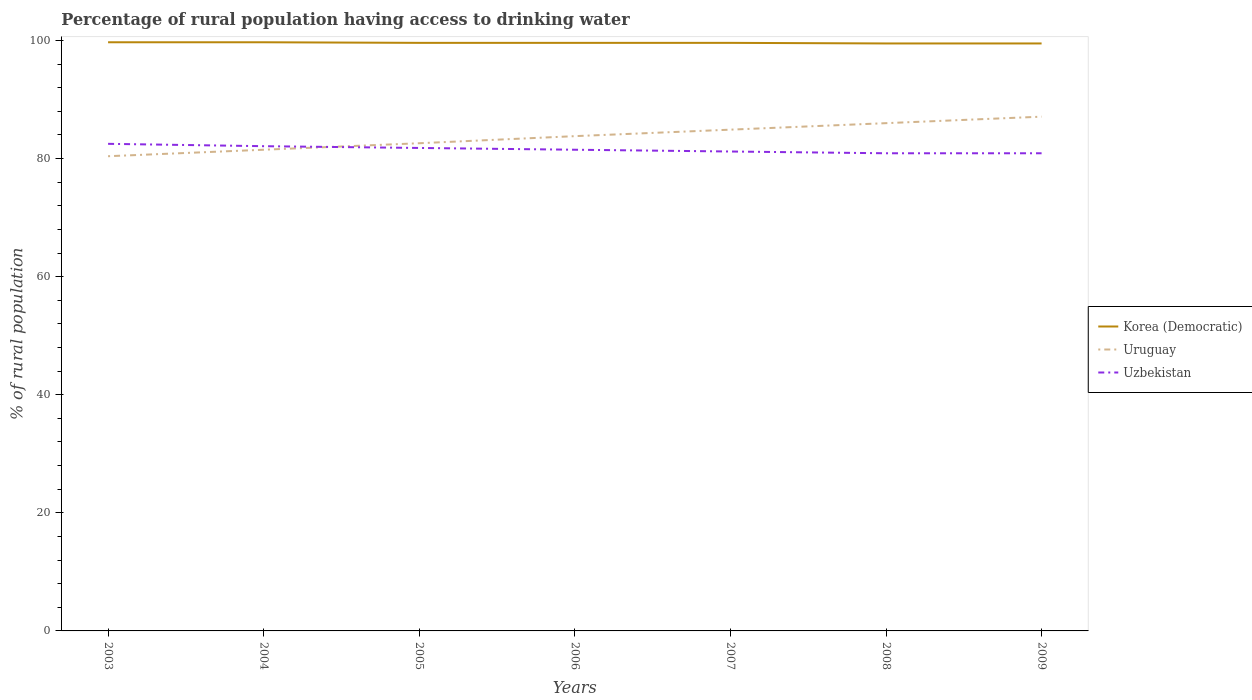How many different coloured lines are there?
Keep it short and to the point. 3. Across all years, what is the maximum percentage of rural population having access to drinking water in Uruguay?
Your answer should be compact. 80.4. What is the difference between the highest and the second highest percentage of rural population having access to drinking water in Korea (Democratic)?
Your answer should be very brief. 0.2. Is the percentage of rural population having access to drinking water in Korea (Democratic) strictly greater than the percentage of rural population having access to drinking water in Uruguay over the years?
Your answer should be very brief. No. How many lines are there?
Make the answer very short. 3. How many years are there in the graph?
Your response must be concise. 7. Are the values on the major ticks of Y-axis written in scientific E-notation?
Your answer should be compact. No. Does the graph contain any zero values?
Keep it short and to the point. No. Does the graph contain grids?
Make the answer very short. No. Where does the legend appear in the graph?
Provide a short and direct response. Center right. How many legend labels are there?
Provide a succinct answer. 3. How are the legend labels stacked?
Your response must be concise. Vertical. What is the title of the graph?
Offer a terse response. Percentage of rural population having access to drinking water. Does "Armenia" appear as one of the legend labels in the graph?
Give a very brief answer. No. What is the label or title of the X-axis?
Make the answer very short. Years. What is the label or title of the Y-axis?
Provide a short and direct response. % of rural population. What is the % of rural population of Korea (Democratic) in 2003?
Give a very brief answer. 99.7. What is the % of rural population of Uruguay in 2003?
Your answer should be very brief. 80.4. What is the % of rural population of Uzbekistan in 2003?
Your answer should be very brief. 82.5. What is the % of rural population of Korea (Democratic) in 2004?
Provide a succinct answer. 99.7. What is the % of rural population in Uruguay in 2004?
Your answer should be very brief. 81.5. What is the % of rural population in Uzbekistan in 2004?
Your response must be concise. 82.1. What is the % of rural population of Korea (Democratic) in 2005?
Offer a terse response. 99.6. What is the % of rural population in Uruguay in 2005?
Provide a short and direct response. 82.6. What is the % of rural population in Uzbekistan in 2005?
Offer a terse response. 81.8. What is the % of rural population in Korea (Democratic) in 2006?
Offer a terse response. 99.6. What is the % of rural population of Uruguay in 2006?
Your answer should be compact. 83.8. What is the % of rural population of Uzbekistan in 2006?
Give a very brief answer. 81.5. What is the % of rural population in Korea (Democratic) in 2007?
Your answer should be very brief. 99.6. What is the % of rural population of Uruguay in 2007?
Offer a terse response. 84.9. What is the % of rural population of Uzbekistan in 2007?
Make the answer very short. 81.2. What is the % of rural population in Korea (Democratic) in 2008?
Keep it short and to the point. 99.5. What is the % of rural population of Uruguay in 2008?
Ensure brevity in your answer.  86. What is the % of rural population of Uzbekistan in 2008?
Offer a very short reply. 80.9. What is the % of rural population of Korea (Democratic) in 2009?
Offer a terse response. 99.5. What is the % of rural population in Uruguay in 2009?
Keep it short and to the point. 87.1. What is the % of rural population of Uzbekistan in 2009?
Your response must be concise. 80.9. Across all years, what is the maximum % of rural population in Korea (Democratic)?
Your response must be concise. 99.7. Across all years, what is the maximum % of rural population of Uruguay?
Your answer should be compact. 87.1. Across all years, what is the maximum % of rural population of Uzbekistan?
Provide a succinct answer. 82.5. Across all years, what is the minimum % of rural population of Korea (Democratic)?
Offer a very short reply. 99.5. Across all years, what is the minimum % of rural population in Uruguay?
Keep it short and to the point. 80.4. Across all years, what is the minimum % of rural population in Uzbekistan?
Ensure brevity in your answer.  80.9. What is the total % of rural population in Korea (Democratic) in the graph?
Make the answer very short. 697.2. What is the total % of rural population in Uruguay in the graph?
Offer a terse response. 586.3. What is the total % of rural population in Uzbekistan in the graph?
Offer a very short reply. 570.9. What is the difference between the % of rural population of Uruguay in 2003 and that in 2004?
Offer a very short reply. -1.1. What is the difference between the % of rural population of Uzbekistan in 2003 and that in 2005?
Provide a short and direct response. 0.7. What is the difference between the % of rural population of Uruguay in 2003 and that in 2006?
Your answer should be compact. -3.4. What is the difference between the % of rural population of Korea (Democratic) in 2003 and that in 2008?
Your response must be concise. 0.2. What is the difference between the % of rural population in Korea (Democratic) in 2003 and that in 2009?
Your answer should be compact. 0.2. What is the difference between the % of rural population of Korea (Democratic) in 2004 and that in 2005?
Your answer should be very brief. 0.1. What is the difference between the % of rural population of Uzbekistan in 2004 and that in 2005?
Give a very brief answer. 0.3. What is the difference between the % of rural population in Uruguay in 2004 and that in 2006?
Your answer should be very brief. -2.3. What is the difference between the % of rural population in Uzbekistan in 2004 and that in 2007?
Keep it short and to the point. 0.9. What is the difference between the % of rural population of Uruguay in 2004 and that in 2008?
Your response must be concise. -4.5. What is the difference between the % of rural population of Korea (Democratic) in 2004 and that in 2009?
Your response must be concise. 0.2. What is the difference between the % of rural population in Uruguay in 2004 and that in 2009?
Your answer should be very brief. -5.6. What is the difference between the % of rural population in Uzbekistan in 2004 and that in 2009?
Your response must be concise. 1.2. What is the difference between the % of rural population in Korea (Democratic) in 2005 and that in 2006?
Offer a terse response. 0. What is the difference between the % of rural population in Uruguay in 2005 and that in 2006?
Offer a terse response. -1.2. What is the difference between the % of rural population of Uzbekistan in 2005 and that in 2006?
Your response must be concise. 0.3. What is the difference between the % of rural population in Uruguay in 2005 and that in 2007?
Your answer should be compact. -2.3. What is the difference between the % of rural population of Uzbekistan in 2005 and that in 2007?
Offer a very short reply. 0.6. What is the difference between the % of rural population in Korea (Democratic) in 2005 and that in 2008?
Make the answer very short. 0.1. What is the difference between the % of rural population of Uzbekistan in 2006 and that in 2007?
Your response must be concise. 0.3. What is the difference between the % of rural population of Uruguay in 2006 and that in 2008?
Provide a short and direct response. -2.2. What is the difference between the % of rural population of Uzbekistan in 2006 and that in 2008?
Provide a succinct answer. 0.6. What is the difference between the % of rural population of Korea (Democratic) in 2006 and that in 2009?
Provide a short and direct response. 0.1. What is the difference between the % of rural population of Uzbekistan in 2006 and that in 2009?
Ensure brevity in your answer.  0.6. What is the difference between the % of rural population of Korea (Democratic) in 2007 and that in 2008?
Make the answer very short. 0.1. What is the difference between the % of rural population of Uruguay in 2007 and that in 2008?
Your answer should be compact. -1.1. What is the difference between the % of rural population in Korea (Democratic) in 2007 and that in 2009?
Keep it short and to the point. 0.1. What is the difference between the % of rural population in Uruguay in 2007 and that in 2009?
Offer a terse response. -2.2. What is the difference between the % of rural population in Korea (Democratic) in 2008 and that in 2009?
Make the answer very short. 0. What is the difference between the % of rural population of Uzbekistan in 2008 and that in 2009?
Give a very brief answer. 0. What is the difference between the % of rural population in Korea (Democratic) in 2003 and the % of rural population in Uzbekistan in 2004?
Keep it short and to the point. 17.6. What is the difference between the % of rural population of Uruguay in 2003 and the % of rural population of Uzbekistan in 2004?
Your response must be concise. -1.7. What is the difference between the % of rural population of Korea (Democratic) in 2003 and the % of rural population of Uzbekistan in 2005?
Offer a very short reply. 17.9. What is the difference between the % of rural population of Uruguay in 2003 and the % of rural population of Uzbekistan in 2005?
Make the answer very short. -1.4. What is the difference between the % of rural population of Korea (Democratic) in 2003 and the % of rural population of Uruguay in 2007?
Give a very brief answer. 14.8. What is the difference between the % of rural population of Korea (Democratic) in 2003 and the % of rural population of Uzbekistan in 2007?
Provide a succinct answer. 18.5. What is the difference between the % of rural population in Korea (Democratic) in 2003 and the % of rural population in Uruguay in 2008?
Your response must be concise. 13.7. What is the difference between the % of rural population of Korea (Democratic) in 2004 and the % of rural population of Uruguay in 2005?
Your answer should be very brief. 17.1. What is the difference between the % of rural population of Korea (Democratic) in 2004 and the % of rural population of Uruguay in 2006?
Keep it short and to the point. 15.9. What is the difference between the % of rural population in Uruguay in 2004 and the % of rural population in Uzbekistan in 2007?
Offer a terse response. 0.3. What is the difference between the % of rural population in Korea (Democratic) in 2004 and the % of rural population in Uzbekistan in 2008?
Offer a very short reply. 18.8. What is the difference between the % of rural population in Uruguay in 2004 and the % of rural population in Uzbekistan in 2008?
Make the answer very short. 0.6. What is the difference between the % of rural population in Korea (Democratic) in 2004 and the % of rural population in Uruguay in 2009?
Your response must be concise. 12.6. What is the difference between the % of rural population of Uruguay in 2004 and the % of rural population of Uzbekistan in 2009?
Offer a terse response. 0.6. What is the difference between the % of rural population in Korea (Democratic) in 2005 and the % of rural population in Uruguay in 2006?
Your response must be concise. 15.8. What is the difference between the % of rural population of Korea (Democratic) in 2005 and the % of rural population of Uzbekistan in 2006?
Your answer should be compact. 18.1. What is the difference between the % of rural population of Korea (Democratic) in 2005 and the % of rural population of Uruguay in 2007?
Provide a short and direct response. 14.7. What is the difference between the % of rural population in Korea (Democratic) in 2005 and the % of rural population in Uruguay in 2008?
Your answer should be very brief. 13.6. What is the difference between the % of rural population in Korea (Democratic) in 2005 and the % of rural population in Uzbekistan in 2008?
Give a very brief answer. 18.7. What is the difference between the % of rural population of Uruguay in 2005 and the % of rural population of Uzbekistan in 2008?
Make the answer very short. 1.7. What is the difference between the % of rural population in Korea (Democratic) in 2006 and the % of rural population in Uruguay in 2007?
Your answer should be compact. 14.7. What is the difference between the % of rural population of Korea (Democratic) in 2006 and the % of rural population of Uzbekistan in 2007?
Offer a very short reply. 18.4. What is the difference between the % of rural population of Uruguay in 2006 and the % of rural population of Uzbekistan in 2008?
Keep it short and to the point. 2.9. What is the difference between the % of rural population of Korea (Democratic) in 2007 and the % of rural population of Uruguay in 2008?
Offer a terse response. 13.6. What is the difference between the % of rural population in Uruguay in 2007 and the % of rural population in Uzbekistan in 2008?
Offer a terse response. 4. What is the difference between the % of rural population in Korea (Democratic) in 2008 and the % of rural population in Uruguay in 2009?
Ensure brevity in your answer.  12.4. What is the difference between the % of rural population in Korea (Democratic) in 2008 and the % of rural population in Uzbekistan in 2009?
Make the answer very short. 18.6. What is the average % of rural population of Korea (Democratic) per year?
Provide a succinct answer. 99.6. What is the average % of rural population in Uruguay per year?
Provide a succinct answer. 83.76. What is the average % of rural population of Uzbekistan per year?
Provide a short and direct response. 81.56. In the year 2003, what is the difference between the % of rural population of Korea (Democratic) and % of rural population of Uruguay?
Ensure brevity in your answer.  19.3. In the year 2005, what is the difference between the % of rural population in Korea (Democratic) and % of rural population in Uruguay?
Offer a terse response. 17. In the year 2005, what is the difference between the % of rural population of Uruguay and % of rural population of Uzbekistan?
Provide a succinct answer. 0.8. In the year 2007, what is the difference between the % of rural population of Korea (Democratic) and % of rural population of Uzbekistan?
Give a very brief answer. 18.4. In the year 2007, what is the difference between the % of rural population in Uruguay and % of rural population in Uzbekistan?
Give a very brief answer. 3.7. In the year 2008, what is the difference between the % of rural population in Korea (Democratic) and % of rural population in Uzbekistan?
Your answer should be very brief. 18.6. In the year 2008, what is the difference between the % of rural population in Uruguay and % of rural population in Uzbekistan?
Offer a very short reply. 5.1. In the year 2009, what is the difference between the % of rural population of Korea (Democratic) and % of rural population of Uruguay?
Keep it short and to the point. 12.4. What is the ratio of the % of rural population in Korea (Democratic) in 2003 to that in 2004?
Ensure brevity in your answer.  1. What is the ratio of the % of rural population of Uruguay in 2003 to that in 2004?
Offer a terse response. 0.99. What is the ratio of the % of rural population in Uzbekistan in 2003 to that in 2004?
Your response must be concise. 1. What is the ratio of the % of rural population in Korea (Democratic) in 2003 to that in 2005?
Keep it short and to the point. 1. What is the ratio of the % of rural population in Uruguay in 2003 to that in 2005?
Offer a terse response. 0.97. What is the ratio of the % of rural population in Uzbekistan in 2003 to that in 2005?
Ensure brevity in your answer.  1.01. What is the ratio of the % of rural population in Korea (Democratic) in 2003 to that in 2006?
Offer a very short reply. 1. What is the ratio of the % of rural population of Uruguay in 2003 to that in 2006?
Provide a short and direct response. 0.96. What is the ratio of the % of rural population of Uzbekistan in 2003 to that in 2006?
Provide a short and direct response. 1.01. What is the ratio of the % of rural population of Korea (Democratic) in 2003 to that in 2007?
Ensure brevity in your answer.  1. What is the ratio of the % of rural population in Uruguay in 2003 to that in 2007?
Offer a very short reply. 0.95. What is the ratio of the % of rural population in Uruguay in 2003 to that in 2008?
Keep it short and to the point. 0.93. What is the ratio of the % of rural population in Uzbekistan in 2003 to that in 2008?
Provide a succinct answer. 1.02. What is the ratio of the % of rural population in Korea (Democratic) in 2003 to that in 2009?
Keep it short and to the point. 1. What is the ratio of the % of rural population of Uzbekistan in 2003 to that in 2009?
Provide a succinct answer. 1.02. What is the ratio of the % of rural population in Korea (Democratic) in 2004 to that in 2005?
Offer a terse response. 1. What is the ratio of the % of rural population of Uruguay in 2004 to that in 2005?
Provide a succinct answer. 0.99. What is the ratio of the % of rural population of Uruguay in 2004 to that in 2006?
Your response must be concise. 0.97. What is the ratio of the % of rural population of Uzbekistan in 2004 to that in 2006?
Your answer should be very brief. 1.01. What is the ratio of the % of rural population in Korea (Democratic) in 2004 to that in 2007?
Keep it short and to the point. 1. What is the ratio of the % of rural population in Uruguay in 2004 to that in 2007?
Provide a succinct answer. 0.96. What is the ratio of the % of rural population in Uzbekistan in 2004 to that in 2007?
Your answer should be very brief. 1.01. What is the ratio of the % of rural population of Korea (Democratic) in 2004 to that in 2008?
Offer a terse response. 1. What is the ratio of the % of rural population in Uruguay in 2004 to that in 2008?
Provide a succinct answer. 0.95. What is the ratio of the % of rural population in Uzbekistan in 2004 to that in 2008?
Provide a short and direct response. 1.01. What is the ratio of the % of rural population of Korea (Democratic) in 2004 to that in 2009?
Make the answer very short. 1. What is the ratio of the % of rural population of Uruguay in 2004 to that in 2009?
Keep it short and to the point. 0.94. What is the ratio of the % of rural population in Uzbekistan in 2004 to that in 2009?
Offer a very short reply. 1.01. What is the ratio of the % of rural population of Uruguay in 2005 to that in 2006?
Make the answer very short. 0.99. What is the ratio of the % of rural population of Uzbekistan in 2005 to that in 2006?
Your response must be concise. 1. What is the ratio of the % of rural population of Uruguay in 2005 to that in 2007?
Your response must be concise. 0.97. What is the ratio of the % of rural population of Uzbekistan in 2005 to that in 2007?
Offer a terse response. 1.01. What is the ratio of the % of rural population in Korea (Democratic) in 2005 to that in 2008?
Your answer should be compact. 1. What is the ratio of the % of rural population of Uruguay in 2005 to that in 2008?
Give a very brief answer. 0.96. What is the ratio of the % of rural population in Uzbekistan in 2005 to that in 2008?
Give a very brief answer. 1.01. What is the ratio of the % of rural population in Korea (Democratic) in 2005 to that in 2009?
Your response must be concise. 1. What is the ratio of the % of rural population of Uruguay in 2005 to that in 2009?
Give a very brief answer. 0.95. What is the ratio of the % of rural population in Uzbekistan in 2005 to that in 2009?
Make the answer very short. 1.01. What is the ratio of the % of rural population in Uruguay in 2006 to that in 2007?
Make the answer very short. 0.99. What is the ratio of the % of rural population of Uzbekistan in 2006 to that in 2007?
Ensure brevity in your answer.  1. What is the ratio of the % of rural population of Uruguay in 2006 to that in 2008?
Keep it short and to the point. 0.97. What is the ratio of the % of rural population in Uzbekistan in 2006 to that in 2008?
Your answer should be compact. 1.01. What is the ratio of the % of rural population of Korea (Democratic) in 2006 to that in 2009?
Your response must be concise. 1. What is the ratio of the % of rural population in Uruguay in 2006 to that in 2009?
Your response must be concise. 0.96. What is the ratio of the % of rural population of Uzbekistan in 2006 to that in 2009?
Provide a succinct answer. 1.01. What is the ratio of the % of rural population of Uruguay in 2007 to that in 2008?
Your response must be concise. 0.99. What is the ratio of the % of rural population of Uruguay in 2007 to that in 2009?
Offer a terse response. 0.97. What is the ratio of the % of rural population in Uruguay in 2008 to that in 2009?
Provide a short and direct response. 0.99. What is the difference between the highest and the second highest % of rural population in Korea (Democratic)?
Ensure brevity in your answer.  0. What is the difference between the highest and the second highest % of rural population of Uruguay?
Make the answer very short. 1.1. 